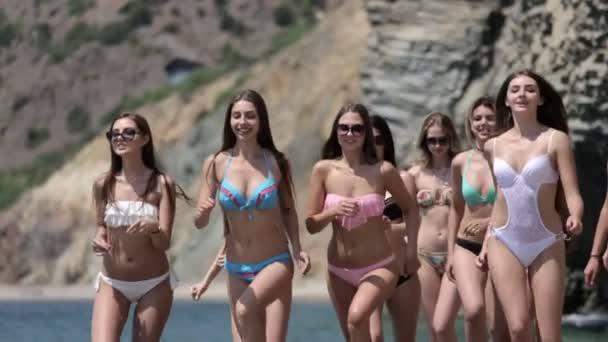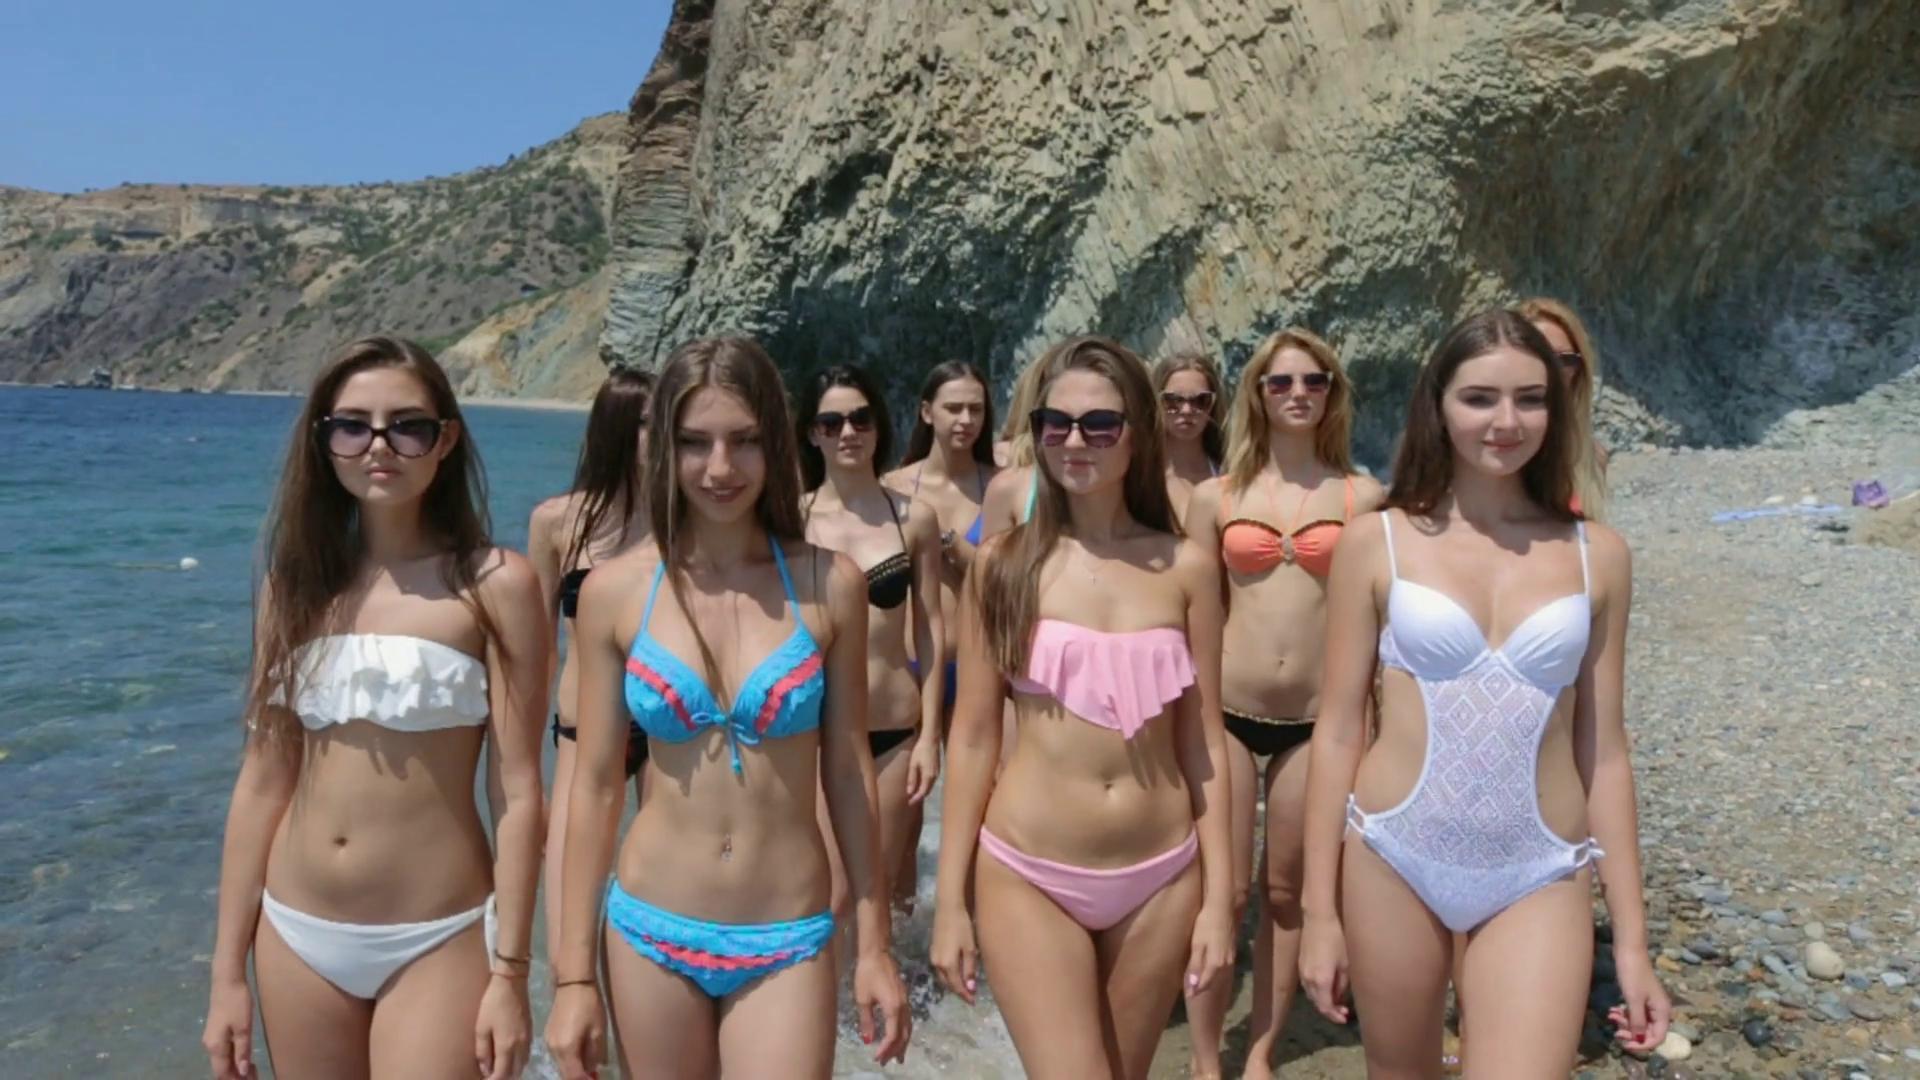The first image is the image on the left, the second image is the image on the right. For the images shown, is this caption "All bikini models are standing up and have their bodies facing the front." true? Answer yes or no. Yes. The first image is the image on the left, the second image is the image on the right. For the images displayed, is the sentence "One of the images is focused on three girls wearing bikinis." factually correct? Answer yes or no. No. 